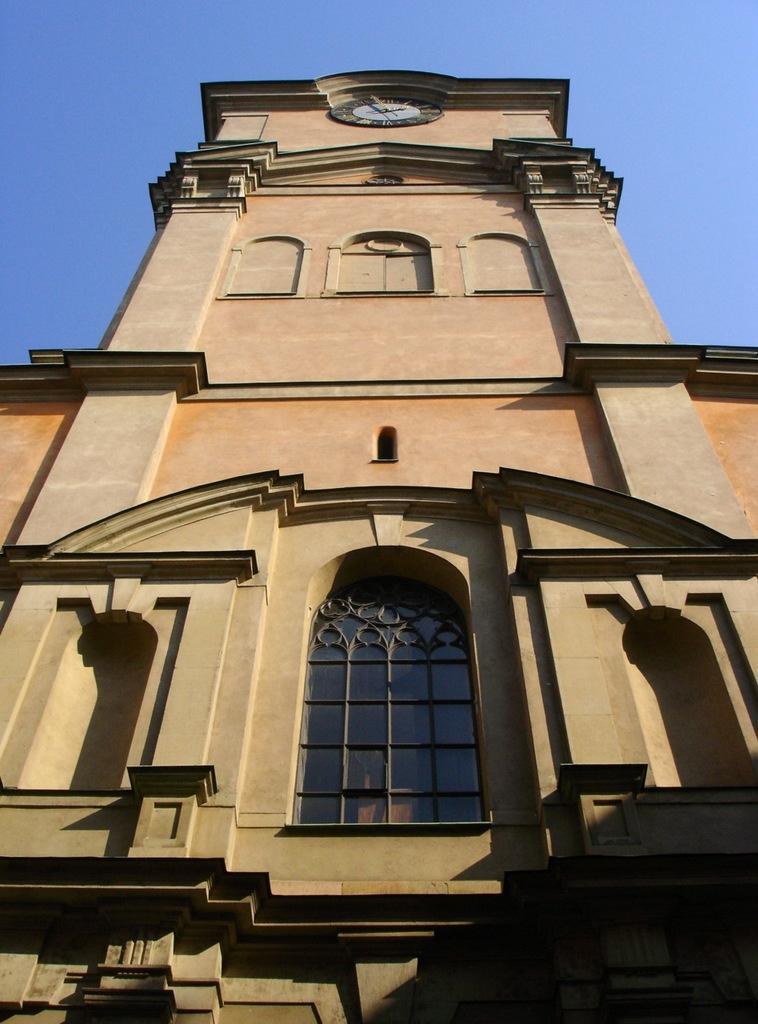How would you summarize this image in a sentence or two? There is a tall building, it has a single window and above the building there is a clock fit in the middle of the wall, there are nice carvings done to the building and the image is captured from the ground. 